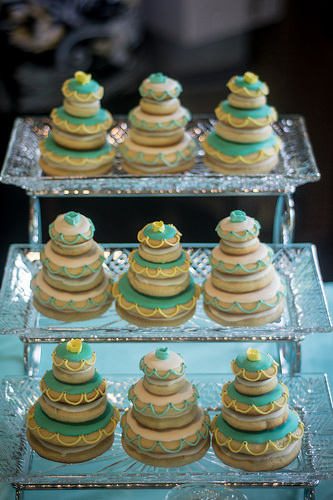<image>
Is the cake under the cake? Yes. The cake is positioned underneath the cake, with the cake above it in the vertical space. Where is the cookie stack in relation to the cookie stack? Is it under the cookie stack? Yes. The cookie stack is positioned underneath the cookie stack, with the cookie stack above it in the vertical space. 